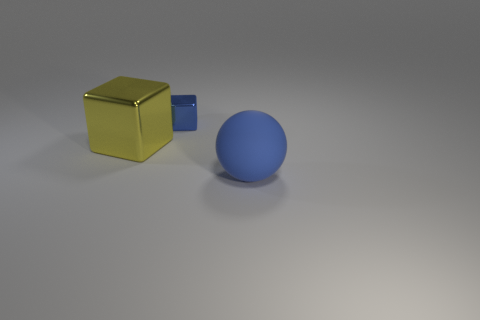Is there anything else that is made of the same material as the blue sphere?
Ensure brevity in your answer.  No. Does the metallic thing that is to the right of the large yellow metallic block have the same size as the rubber thing in front of the large block?
Offer a terse response. No. There is a thing that is both in front of the tiny shiny block and behind the big blue rubber ball; what material is it?
Keep it short and to the point. Metal. How many big spheres are left of the big blue matte ball?
Give a very brief answer. 0. Are there any other things that have the same size as the yellow metal thing?
Keep it short and to the point. Yes. There is a thing that is the same material as the large cube; what is its color?
Offer a terse response. Blue. Is the shape of the blue rubber thing the same as the blue metallic object?
Provide a short and direct response. No. How many large objects are in front of the big yellow block and on the left side of the matte ball?
Your response must be concise. 0. How many rubber objects are big gray balls or big cubes?
Your response must be concise. 0. What size is the blue thing that is right of the blue object behind the rubber thing?
Your response must be concise. Large. 